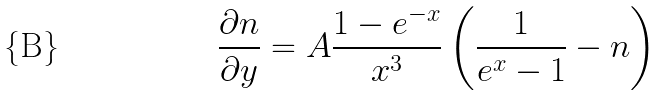<formula> <loc_0><loc_0><loc_500><loc_500>\frac { \partial n } { \partial y } = A \frac { 1 - e ^ { - x } } { x ^ { 3 } } \left ( \frac { 1 } { e ^ { x } - 1 } - n \right )</formula> 